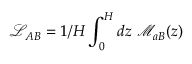<formula> <loc_0><loc_0><loc_500><loc_500>\mathcal { L } _ { A B } = 1 / H \int _ { 0 } ^ { H } d z \ \mathcal { M } _ { a B } ( z )</formula> 